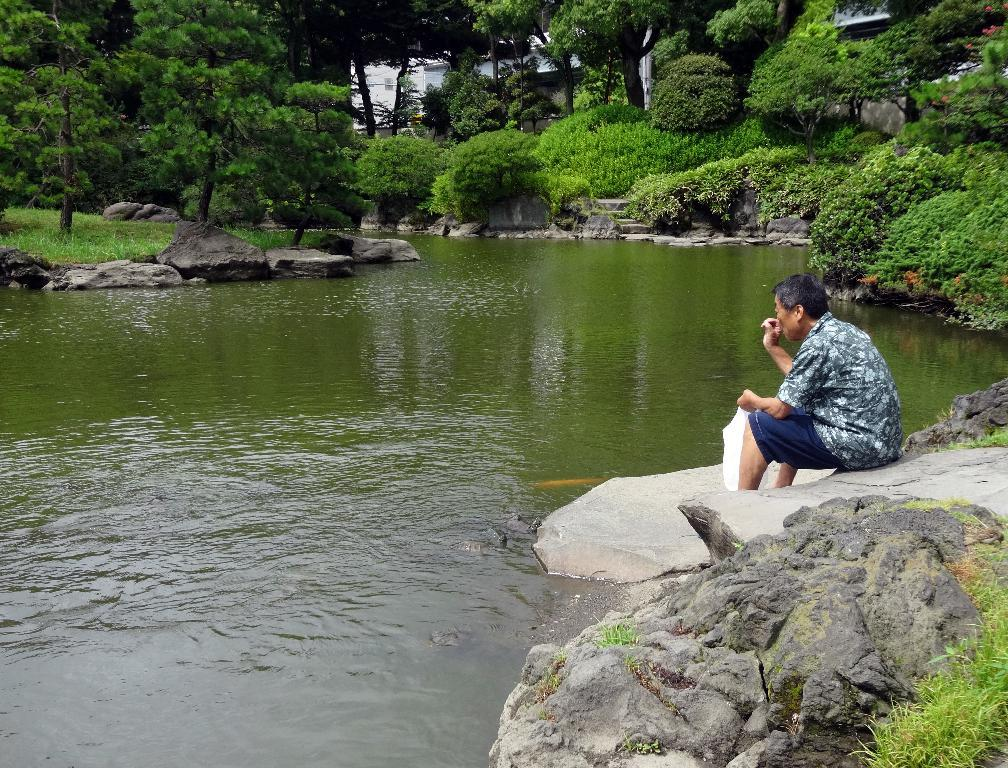What can be seen in the foreground of the picture? In the foreground of the picture, there are rocks, grass, a man, water, and water animals. What types of vegetation are present in the foreground? There is grass in the foreground. What is the man in the foreground doing? The man's actions are not specified in the facts, so we cannot determine what he is doing. What is visible at the top of the picture? At the top of the picture, there are plants, trees, rocks, water, and a building. How many clouds can be seen in the picture? There is no mention of clouds in the provided facts, so we cannot determine the number of clouds in the picture. What type of balls are being used by the water animals in the picture? There is no mention of balls in the provided facts, so we cannot determine if any balls are present in the picture. 